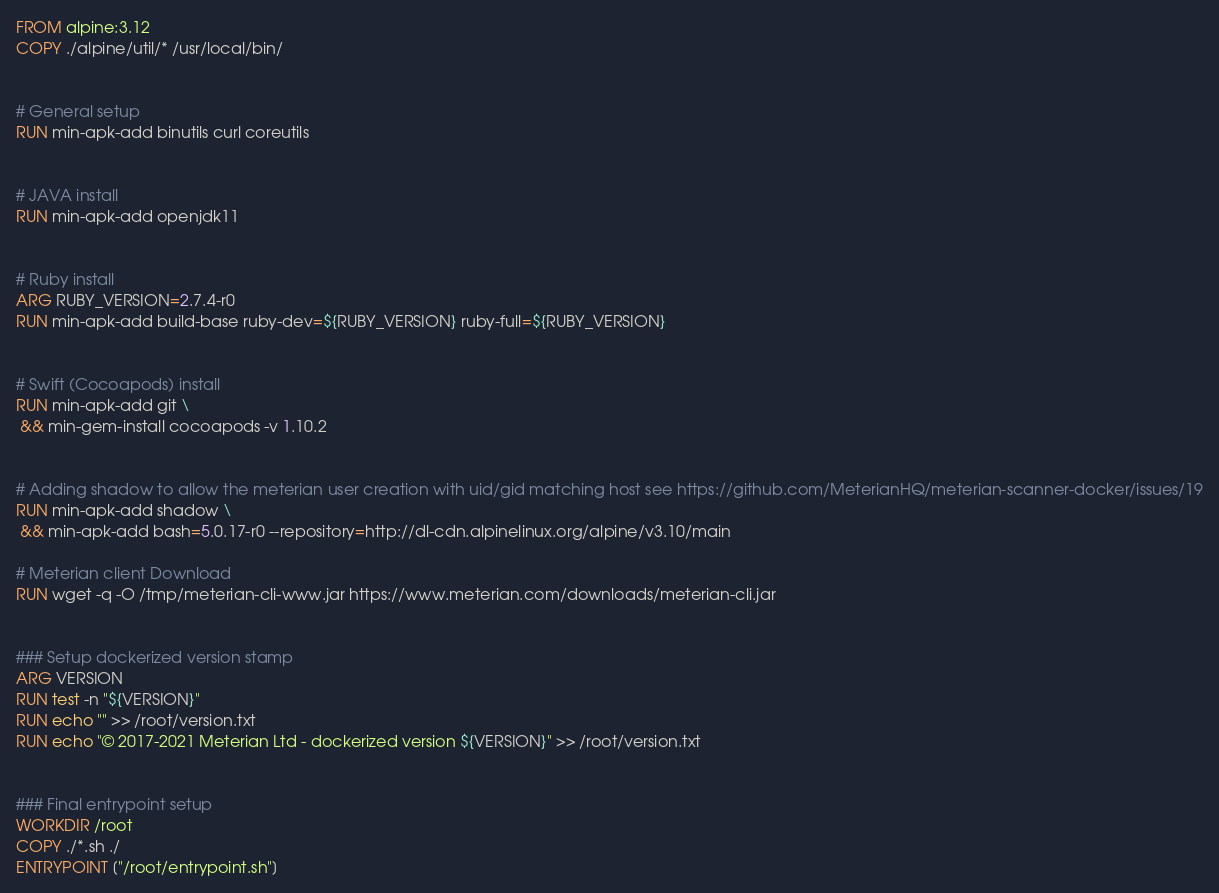Convert code to text. <code><loc_0><loc_0><loc_500><loc_500><_Dockerfile_>FROM alpine:3.12
COPY ./alpine/util/* /usr/local/bin/


# General setup
RUN min-apk-add binutils curl coreutils


# JAVA install
RUN min-apk-add openjdk11


# Ruby install
ARG RUBY_VERSION=2.7.4-r0
RUN min-apk-add build-base ruby-dev=${RUBY_VERSION} ruby-full=${RUBY_VERSION}


# Swift (Cocoapods) install
RUN min-apk-add git \
 && min-gem-install cocoapods -v 1.10.2


# Adding shadow to allow the meterian user creation with uid/gid matching host see https://github.com/MeterianHQ/meterian-scanner-docker/issues/19
RUN min-apk-add shadow \
 && min-apk-add bash=5.0.17-r0 --repository=http://dl-cdn.alpinelinux.org/alpine/v3.10/main

# Meterian client Download
RUN wget -q -O /tmp/meterian-cli-www.jar https://www.meterian.com/downloads/meterian-cli.jar


### Setup dockerized version stamp
ARG VERSION
RUN test -n "${VERSION}"
RUN echo "" >> /root/version.txt
RUN echo "© 2017-2021 Meterian Ltd - dockerized version ${VERSION}" >> /root/version.txt


### Final entrypoint setup
WORKDIR /root
COPY ./*.sh ./
ENTRYPOINT ["/root/entrypoint.sh"]
</code> 